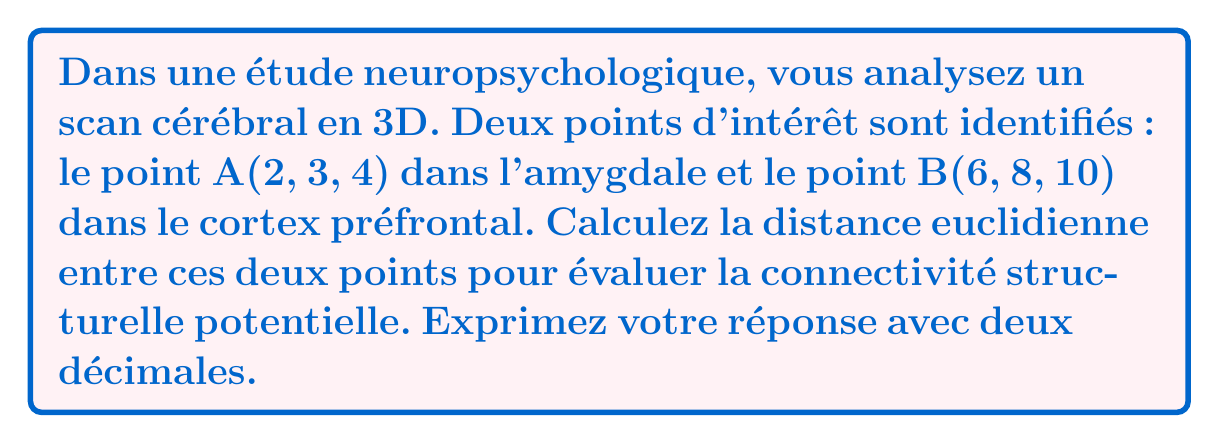Show me your answer to this math problem. Pour calculer la distance euclidienne entre deux points dans un espace tridimensionnel, nous utilisons la formule suivante :

$$ d = \sqrt{(x_2-x_1)^2 + (y_2-y_1)^2 + (z_2-z_1)^2} $$

Où $(x_1, y_1, z_1)$ sont les coordonnées du premier point et $(x_2, y_2, z_2)$ sont les coordonnées du second point.

Étapes de calcul :

1) Identifions les coordonnées :
   Point A (amygdale) : $(x_1, y_1, z_1) = (2, 3, 4)$
   Point B (cortex préfrontal) : $(x_2, y_2, z_2) = (6, 8, 10)$

2) Calculons les différences :
   $x_2 - x_1 = 6 - 2 = 4$
   $y_2 - y_1 = 8 - 3 = 5$
   $z_2 - z_1 = 10 - 4 = 6$

3) Appliquons la formule :
   $$ d = \sqrt{(4)^2 + (5)^2 + (6)^2} $$

4) Simplifions :
   $$ d = \sqrt{16 + 25 + 36} = \sqrt{77} $$

5) Calculons la racine carrée et arrondissons à deux décimales :
   $$ d \approx 8,77 $$

Cette distance représente la longueur de la ligne droite entre les deux points d'intérêt dans le cerveau, ce qui pourrait indiquer la connectivité structurelle potentielle entre l'amygdale et le cortex préfrontal dans ce scan cérébral particulier.
Answer: 8,77 unités 